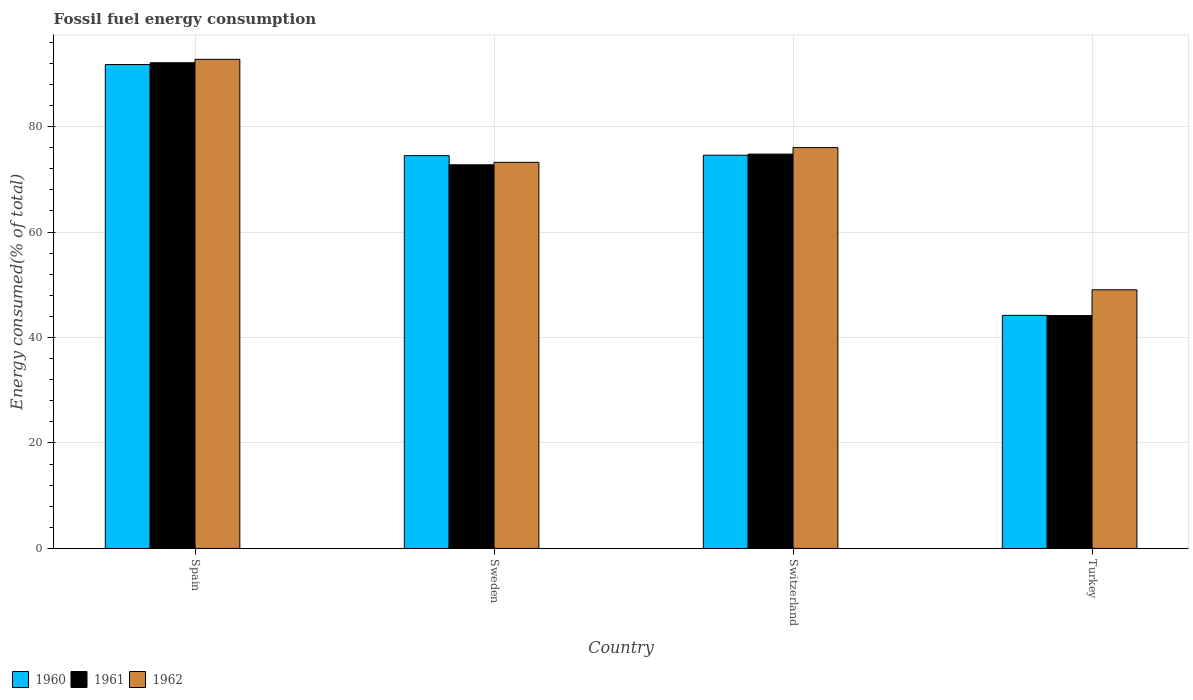How many groups of bars are there?
Your answer should be very brief. 4. Are the number of bars per tick equal to the number of legend labels?
Provide a short and direct response. Yes. Are the number of bars on each tick of the X-axis equal?
Your answer should be compact. Yes. How many bars are there on the 1st tick from the left?
Your answer should be very brief. 3. What is the label of the 2nd group of bars from the left?
Your answer should be compact. Sweden. In how many cases, is the number of bars for a given country not equal to the number of legend labels?
Ensure brevity in your answer.  0. What is the percentage of energy consumed in 1961 in Turkey?
Your answer should be very brief. 44.16. Across all countries, what is the maximum percentage of energy consumed in 1960?
Ensure brevity in your answer.  91.77. Across all countries, what is the minimum percentage of energy consumed in 1961?
Provide a succinct answer. 44.16. In which country was the percentage of energy consumed in 1961 maximum?
Give a very brief answer. Spain. In which country was the percentage of energy consumed in 1960 minimum?
Ensure brevity in your answer.  Turkey. What is the total percentage of energy consumed in 1962 in the graph?
Give a very brief answer. 291.05. What is the difference between the percentage of energy consumed in 1962 in Spain and that in Switzerland?
Provide a short and direct response. 16.74. What is the difference between the percentage of energy consumed in 1960 in Sweden and the percentage of energy consumed in 1961 in Turkey?
Give a very brief answer. 30.33. What is the average percentage of energy consumed in 1962 per country?
Your answer should be very brief. 72.76. What is the difference between the percentage of energy consumed of/in 1962 and percentage of energy consumed of/in 1960 in Sweden?
Your answer should be compact. -1.27. In how many countries, is the percentage of energy consumed in 1961 greater than 60 %?
Your answer should be compact. 3. What is the ratio of the percentage of energy consumed in 1962 in Sweden to that in Turkey?
Ensure brevity in your answer.  1.49. Is the percentage of energy consumed in 1962 in Sweden less than that in Switzerland?
Keep it short and to the point. Yes. What is the difference between the highest and the second highest percentage of energy consumed in 1960?
Your answer should be compact. -17.19. What is the difference between the highest and the lowest percentage of energy consumed in 1960?
Make the answer very short. 47.57. In how many countries, is the percentage of energy consumed in 1962 greater than the average percentage of energy consumed in 1962 taken over all countries?
Make the answer very short. 3. Are all the bars in the graph horizontal?
Your response must be concise. No. How many countries are there in the graph?
Give a very brief answer. 4. Are the values on the major ticks of Y-axis written in scientific E-notation?
Your answer should be compact. No. Does the graph contain grids?
Your answer should be compact. Yes. How many legend labels are there?
Keep it short and to the point. 3. How are the legend labels stacked?
Provide a short and direct response. Horizontal. What is the title of the graph?
Make the answer very short. Fossil fuel energy consumption. Does "1984" appear as one of the legend labels in the graph?
Your answer should be very brief. No. What is the label or title of the X-axis?
Your answer should be very brief. Country. What is the label or title of the Y-axis?
Ensure brevity in your answer.  Energy consumed(% of total). What is the Energy consumed(% of total) of 1960 in Spain?
Keep it short and to the point. 91.77. What is the Energy consumed(% of total) of 1961 in Spain?
Your response must be concise. 92.1. What is the Energy consumed(% of total) in 1962 in Spain?
Give a very brief answer. 92.75. What is the Energy consumed(% of total) of 1960 in Sweden?
Your answer should be very brief. 74.49. What is the Energy consumed(% of total) in 1961 in Sweden?
Offer a very short reply. 72.75. What is the Energy consumed(% of total) in 1962 in Sweden?
Provide a succinct answer. 73.23. What is the Energy consumed(% of total) of 1960 in Switzerland?
Offer a very short reply. 74.57. What is the Energy consumed(% of total) in 1961 in Switzerland?
Ensure brevity in your answer.  74.78. What is the Energy consumed(% of total) of 1962 in Switzerland?
Provide a succinct answer. 76.02. What is the Energy consumed(% of total) in 1960 in Turkey?
Offer a terse response. 44.2. What is the Energy consumed(% of total) in 1961 in Turkey?
Offer a very short reply. 44.16. What is the Energy consumed(% of total) in 1962 in Turkey?
Your answer should be compact. 49.05. Across all countries, what is the maximum Energy consumed(% of total) of 1960?
Offer a terse response. 91.77. Across all countries, what is the maximum Energy consumed(% of total) in 1961?
Your answer should be very brief. 92.1. Across all countries, what is the maximum Energy consumed(% of total) in 1962?
Provide a short and direct response. 92.75. Across all countries, what is the minimum Energy consumed(% of total) in 1960?
Give a very brief answer. 44.2. Across all countries, what is the minimum Energy consumed(% of total) in 1961?
Provide a succinct answer. 44.16. Across all countries, what is the minimum Energy consumed(% of total) in 1962?
Give a very brief answer. 49.05. What is the total Energy consumed(% of total) in 1960 in the graph?
Ensure brevity in your answer.  285.03. What is the total Energy consumed(% of total) of 1961 in the graph?
Make the answer very short. 283.8. What is the total Energy consumed(% of total) of 1962 in the graph?
Offer a terse response. 291.05. What is the difference between the Energy consumed(% of total) in 1960 in Spain and that in Sweden?
Offer a terse response. 17.27. What is the difference between the Energy consumed(% of total) in 1961 in Spain and that in Sweden?
Your answer should be compact. 19.35. What is the difference between the Energy consumed(% of total) of 1962 in Spain and that in Sweden?
Your answer should be very brief. 19.53. What is the difference between the Energy consumed(% of total) in 1960 in Spain and that in Switzerland?
Offer a very short reply. 17.19. What is the difference between the Energy consumed(% of total) of 1961 in Spain and that in Switzerland?
Your answer should be compact. 17.32. What is the difference between the Energy consumed(% of total) in 1962 in Spain and that in Switzerland?
Offer a very short reply. 16.74. What is the difference between the Energy consumed(% of total) of 1960 in Spain and that in Turkey?
Give a very brief answer. 47.57. What is the difference between the Energy consumed(% of total) in 1961 in Spain and that in Turkey?
Provide a short and direct response. 47.95. What is the difference between the Energy consumed(% of total) of 1962 in Spain and that in Turkey?
Provide a short and direct response. 43.7. What is the difference between the Energy consumed(% of total) in 1960 in Sweden and that in Switzerland?
Your response must be concise. -0.08. What is the difference between the Energy consumed(% of total) of 1961 in Sweden and that in Switzerland?
Ensure brevity in your answer.  -2.03. What is the difference between the Energy consumed(% of total) in 1962 in Sweden and that in Switzerland?
Offer a very short reply. -2.79. What is the difference between the Energy consumed(% of total) of 1960 in Sweden and that in Turkey?
Offer a terse response. 30.29. What is the difference between the Energy consumed(% of total) in 1961 in Sweden and that in Turkey?
Your answer should be compact. 28.59. What is the difference between the Energy consumed(% of total) in 1962 in Sweden and that in Turkey?
Your answer should be very brief. 24.18. What is the difference between the Energy consumed(% of total) in 1960 in Switzerland and that in Turkey?
Your answer should be very brief. 30.37. What is the difference between the Energy consumed(% of total) of 1961 in Switzerland and that in Turkey?
Offer a very short reply. 30.62. What is the difference between the Energy consumed(% of total) in 1962 in Switzerland and that in Turkey?
Give a very brief answer. 26.97. What is the difference between the Energy consumed(% of total) of 1960 in Spain and the Energy consumed(% of total) of 1961 in Sweden?
Ensure brevity in your answer.  19.01. What is the difference between the Energy consumed(% of total) of 1960 in Spain and the Energy consumed(% of total) of 1962 in Sweden?
Give a very brief answer. 18.54. What is the difference between the Energy consumed(% of total) of 1961 in Spain and the Energy consumed(% of total) of 1962 in Sweden?
Keep it short and to the point. 18.88. What is the difference between the Energy consumed(% of total) in 1960 in Spain and the Energy consumed(% of total) in 1961 in Switzerland?
Your answer should be compact. 16.98. What is the difference between the Energy consumed(% of total) in 1960 in Spain and the Energy consumed(% of total) in 1962 in Switzerland?
Ensure brevity in your answer.  15.75. What is the difference between the Energy consumed(% of total) in 1961 in Spain and the Energy consumed(% of total) in 1962 in Switzerland?
Your response must be concise. 16.09. What is the difference between the Energy consumed(% of total) of 1960 in Spain and the Energy consumed(% of total) of 1961 in Turkey?
Give a very brief answer. 47.61. What is the difference between the Energy consumed(% of total) in 1960 in Spain and the Energy consumed(% of total) in 1962 in Turkey?
Make the answer very short. 42.72. What is the difference between the Energy consumed(% of total) in 1961 in Spain and the Energy consumed(% of total) in 1962 in Turkey?
Your answer should be compact. 43.05. What is the difference between the Energy consumed(% of total) in 1960 in Sweden and the Energy consumed(% of total) in 1961 in Switzerland?
Provide a short and direct response. -0.29. What is the difference between the Energy consumed(% of total) in 1960 in Sweden and the Energy consumed(% of total) in 1962 in Switzerland?
Your answer should be very brief. -1.52. What is the difference between the Energy consumed(% of total) in 1961 in Sweden and the Energy consumed(% of total) in 1962 in Switzerland?
Keep it short and to the point. -3.26. What is the difference between the Energy consumed(% of total) in 1960 in Sweden and the Energy consumed(% of total) in 1961 in Turkey?
Your answer should be compact. 30.33. What is the difference between the Energy consumed(% of total) of 1960 in Sweden and the Energy consumed(% of total) of 1962 in Turkey?
Offer a very short reply. 25.44. What is the difference between the Energy consumed(% of total) in 1961 in Sweden and the Energy consumed(% of total) in 1962 in Turkey?
Ensure brevity in your answer.  23.7. What is the difference between the Energy consumed(% of total) of 1960 in Switzerland and the Energy consumed(% of total) of 1961 in Turkey?
Make the answer very short. 30.41. What is the difference between the Energy consumed(% of total) of 1960 in Switzerland and the Energy consumed(% of total) of 1962 in Turkey?
Keep it short and to the point. 25.52. What is the difference between the Energy consumed(% of total) of 1961 in Switzerland and the Energy consumed(% of total) of 1962 in Turkey?
Your answer should be compact. 25.73. What is the average Energy consumed(% of total) of 1960 per country?
Your answer should be compact. 71.26. What is the average Energy consumed(% of total) in 1961 per country?
Ensure brevity in your answer.  70.95. What is the average Energy consumed(% of total) in 1962 per country?
Make the answer very short. 72.76. What is the difference between the Energy consumed(% of total) in 1960 and Energy consumed(% of total) in 1961 in Spain?
Ensure brevity in your answer.  -0.34. What is the difference between the Energy consumed(% of total) of 1960 and Energy consumed(% of total) of 1962 in Spain?
Your answer should be very brief. -0.99. What is the difference between the Energy consumed(% of total) in 1961 and Energy consumed(% of total) in 1962 in Spain?
Keep it short and to the point. -0.65. What is the difference between the Energy consumed(% of total) of 1960 and Energy consumed(% of total) of 1961 in Sweden?
Provide a succinct answer. 1.74. What is the difference between the Energy consumed(% of total) of 1960 and Energy consumed(% of total) of 1962 in Sweden?
Your response must be concise. 1.27. What is the difference between the Energy consumed(% of total) in 1961 and Energy consumed(% of total) in 1962 in Sweden?
Provide a short and direct response. -0.47. What is the difference between the Energy consumed(% of total) of 1960 and Energy consumed(% of total) of 1961 in Switzerland?
Your answer should be compact. -0.21. What is the difference between the Energy consumed(% of total) in 1960 and Energy consumed(% of total) in 1962 in Switzerland?
Give a very brief answer. -1.45. What is the difference between the Energy consumed(% of total) of 1961 and Energy consumed(% of total) of 1962 in Switzerland?
Offer a terse response. -1.23. What is the difference between the Energy consumed(% of total) of 1960 and Energy consumed(% of total) of 1962 in Turkey?
Provide a succinct answer. -4.85. What is the difference between the Energy consumed(% of total) of 1961 and Energy consumed(% of total) of 1962 in Turkey?
Your answer should be compact. -4.89. What is the ratio of the Energy consumed(% of total) in 1960 in Spain to that in Sweden?
Keep it short and to the point. 1.23. What is the ratio of the Energy consumed(% of total) in 1961 in Spain to that in Sweden?
Ensure brevity in your answer.  1.27. What is the ratio of the Energy consumed(% of total) of 1962 in Spain to that in Sweden?
Provide a succinct answer. 1.27. What is the ratio of the Energy consumed(% of total) in 1960 in Spain to that in Switzerland?
Provide a short and direct response. 1.23. What is the ratio of the Energy consumed(% of total) in 1961 in Spain to that in Switzerland?
Offer a very short reply. 1.23. What is the ratio of the Energy consumed(% of total) of 1962 in Spain to that in Switzerland?
Make the answer very short. 1.22. What is the ratio of the Energy consumed(% of total) in 1960 in Spain to that in Turkey?
Offer a very short reply. 2.08. What is the ratio of the Energy consumed(% of total) in 1961 in Spain to that in Turkey?
Give a very brief answer. 2.09. What is the ratio of the Energy consumed(% of total) in 1962 in Spain to that in Turkey?
Provide a short and direct response. 1.89. What is the ratio of the Energy consumed(% of total) in 1960 in Sweden to that in Switzerland?
Your response must be concise. 1. What is the ratio of the Energy consumed(% of total) in 1961 in Sweden to that in Switzerland?
Ensure brevity in your answer.  0.97. What is the ratio of the Energy consumed(% of total) in 1962 in Sweden to that in Switzerland?
Offer a terse response. 0.96. What is the ratio of the Energy consumed(% of total) of 1960 in Sweden to that in Turkey?
Your answer should be very brief. 1.69. What is the ratio of the Energy consumed(% of total) in 1961 in Sweden to that in Turkey?
Your answer should be compact. 1.65. What is the ratio of the Energy consumed(% of total) in 1962 in Sweden to that in Turkey?
Provide a short and direct response. 1.49. What is the ratio of the Energy consumed(% of total) of 1960 in Switzerland to that in Turkey?
Keep it short and to the point. 1.69. What is the ratio of the Energy consumed(% of total) of 1961 in Switzerland to that in Turkey?
Make the answer very short. 1.69. What is the ratio of the Energy consumed(% of total) in 1962 in Switzerland to that in Turkey?
Offer a very short reply. 1.55. What is the difference between the highest and the second highest Energy consumed(% of total) in 1960?
Your answer should be very brief. 17.19. What is the difference between the highest and the second highest Energy consumed(% of total) of 1961?
Offer a terse response. 17.32. What is the difference between the highest and the second highest Energy consumed(% of total) of 1962?
Your answer should be very brief. 16.74. What is the difference between the highest and the lowest Energy consumed(% of total) in 1960?
Give a very brief answer. 47.57. What is the difference between the highest and the lowest Energy consumed(% of total) of 1961?
Provide a short and direct response. 47.95. What is the difference between the highest and the lowest Energy consumed(% of total) in 1962?
Keep it short and to the point. 43.7. 